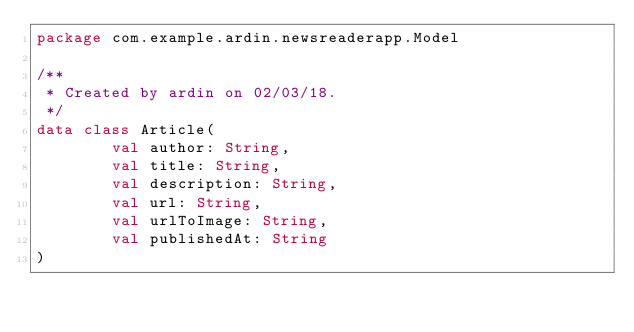Convert code to text. <code><loc_0><loc_0><loc_500><loc_500><_Kotlin_>package com.example.ardin.newsreaderapp.Model

/**
 * Created by ardin on 02/03/18.
 */
data class Article(
        val author: String,
        val title: String,
        val description: String,
        val url: String,
        val urlToImage: String,
        val publishedAt: String
)</code> 